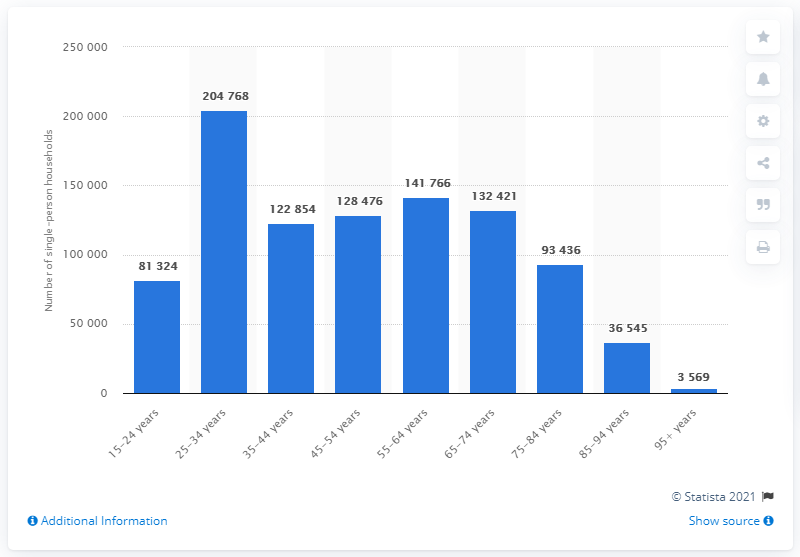List a handful of essential elements in this visual. In 2020, there were 204,768 men living in single-person households in Sweden. 